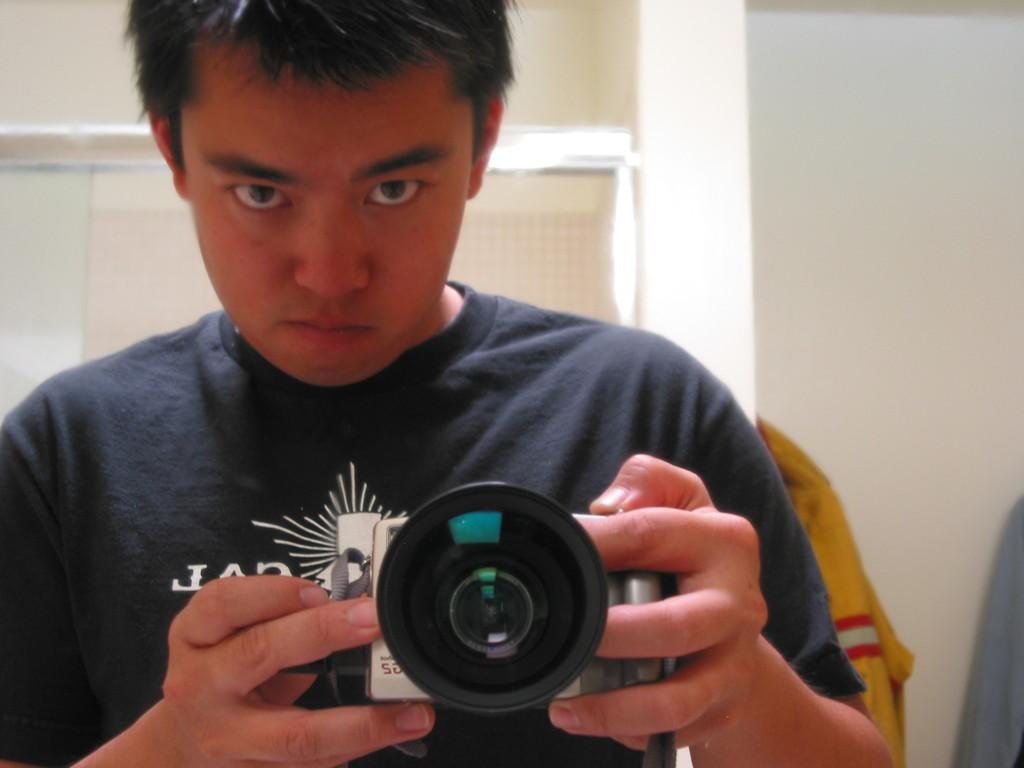What is unique about the perspective of the image? The image is taken in a mirror. What is the person in the image doing? The person is holding a camera in the image. What can be seen in the background of the image? There are clothes, a wall, and a glass door in the background of the image. What type of tools is the carpenter using in the image? There is no carpenter present in the image, nor are there any tools visible. Can you tell me how many drains are visible in the image? There are no drains present in the image. 